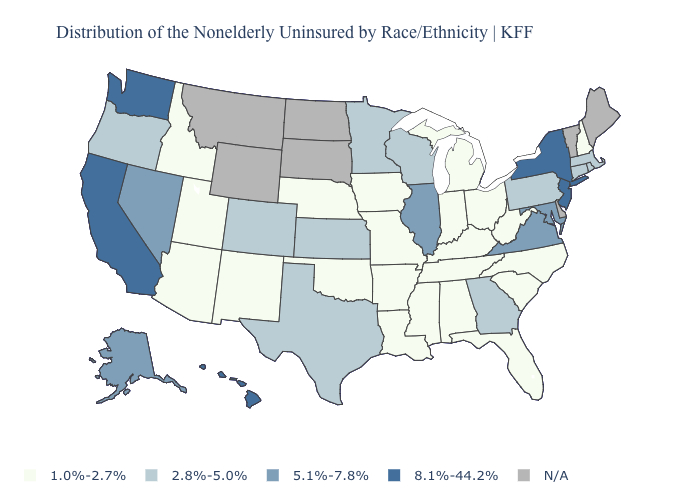Which states have the lowest value in the Northeast?
Short answer required. New Hampshire. How many symbols are there in the legend?
Concise answer only. 5. Name the states that have a value in the range N/A?
Concise answer only. Delaware, Maine, Montana, North Dakota, South Dakota, Vermont, Wyoming. Is the legend a continuous bar?
Concise answer only. No. Among the states that border Idaho , which have the lowest value?
Quick response, please. Utah. Does the map have missing data?
Answer briefly. Yes. Among the states that border Kentucky , which have the highest value?
Write a very short answer. Illinois, Virginia. Name the states that have a value in the range 2.8%-5.0%?
Give a very brief answer. Colorado, Connecticut, Georgia, Kansas, Massachusetts, Minnesota, Oregon, Pennsylvania, Rhode Island, Texas, Wisconsin. Which states have the lowest value in the USA?
Concise answer only. Alabama, Arizona, Arkansas, Florida, Idaho, Indiana, Iowa, Kentucky, Louisiana, Michigan, Mississippi, Missouri, Nebraska, New Hampshire, New Mexico, North Carolina, Ohio, Oklahoma, South Carolina, Tennessee, Utah, West Virginia. What is the value of Kansas?
Short answer required. 2.8%-5.0%. Name the states that have a value in the range 2.8%-5.0%?
Concise answer only. Colorado, Connecticut, Georgia, Kansas, Massachusetts, Minnesota, Oregon, Pennsylvania, Rhode Island, Texas, Wisconsin. Name the states that have a value in the range 1.0%-2.7%?
Concise answer only. Alabama, Arizona, Arkansas, Florida, Idaho, Indiana, Iowa, Kentucky, Louisiana, Michigan, Mississippi, Missouri, Nebraska, New Hampshire, New Mexico, North Carolina, Ohio, Oklahoma, South Carolina, Tennessee, Utah, West Virginia. Among the states that border Arizona , does New Mexico have the lowest value?
Quick response, please. Yes. Among the states that border Minnesota , which have the highest value?
Answer briefly. Wisconsin. What is the highest value in the South ?
Concise answer only. 5.1%-7.8%. 